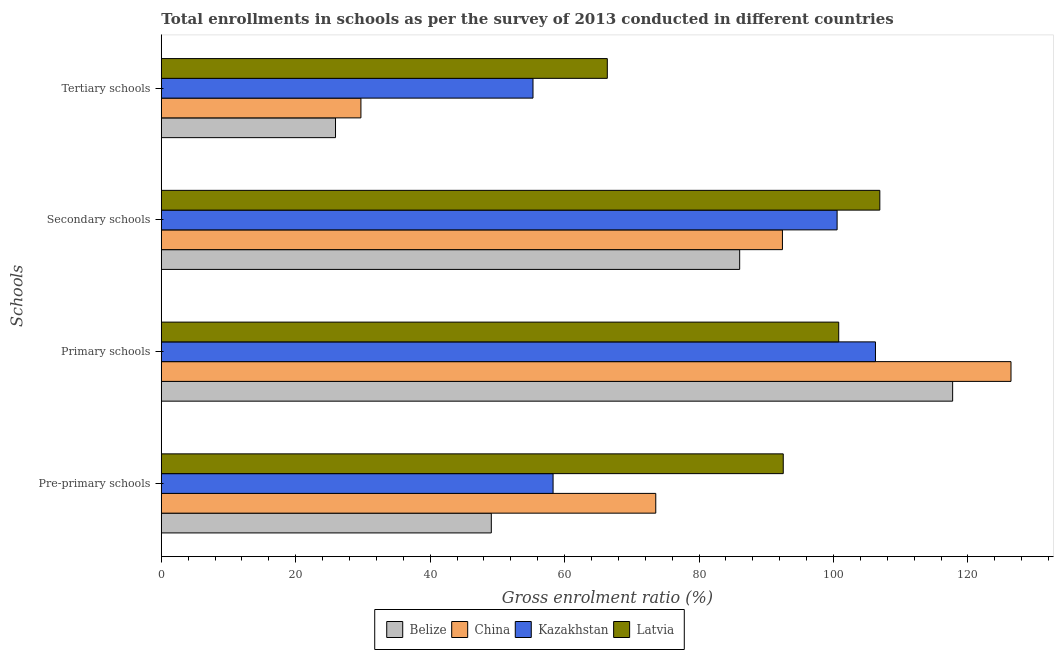How many different coloured bars are there?
Your response must be concise. 4. How many groups of bars are there?
Your answer should be compact. 4. Are the number of bars on each tick of the Y-axis equal?
Your response must be concise. Yes. How many bars are there on the 2nd tick from the top?
Your response must be concise. 4. What is the label of the 1st group of bars from the top?
Provide a short and direct response. Tertiary schools. What is the gross enrolment ratio in primary schools in Belize?
Your response must be concise. 117.73. Across all countries, what is the maximum gross enrolment ratio in tertiary schools?
Offer a terse response. 66.35. Across all countries, what is the minimum gross enrolment ratio in primary schools?
Keep it short and to the point. 100.78. In which country was the gross enrolment ratio in pre-primary schools maximum?
Provide a short and direct response. Latvia. In which country was the gross enrolment ratio in tertiary schools minimum?
Your response must be concise. Belize. What is the total gross enrolment ratio in secondary schools in the graph?
Offer a terse response. 385.9. What is the difference between the gross enrolment ratio in primary schools in Belize and that in Latvia?
Your answer should be very brief. 16.95. What is the difference between the gross enrolment ratio in pre-primary schools in Latvia and the gross enrolment ratio in primary schools in Kazakhstan?
Your answer should be very brief. -13.72. What is the average gross enrolment ratio in tertiary schools per country?
Ensure brevity in your answer.  44.32. What is the difference between the gross enrolment ratio in primary schools and gross enrolment ratio in secondary schools in Kazakhstan?
Ensure brevity in your answer.  5.71. What is the ratio of the gross enrolment ratio in secondary schools in Kazakhstan to that in Belize?
Ensure brevity in your answer.  1.17. Is the gross enrolment ratio in primary schools in Latvia less than that in China?
Provide a short and direct response. Yes. Is the difference between the gross enrolment ratio in primary schools in China and Kazakhstan greater than the difference between the gross enrolment ratio in secondary schools in China and Kazakhstan?
Provide a succinct answer. Yes. What is the difference between the highest and the second highest gross enrolment ratio in tertiary schools?
Keep it short and to the point. 11.06. What is the difference between the highest and the lowest gross enrolment ratio in pre-primary schools?
Make the answer very short. 43.43. Is the sum of the gross enrolment ratio in secondary schools in Latvia and Belize greater than the maximum gross enrolment ratio in pre-primary schools across all countries?
Offer a very short reply. Yes. What does the 2nd bar from the top in Secondary schools represents?
Your answer should be compact. Kazakhstan. What does the 4th bar from the bottom in Pre-primary schools represents?
Keep it short and to the point. Latvia. Is it the case that in every country, the sum of the gross enrolment ratio in pre-primary schools and gross enrolment ratio in primary schools is greater than the gross enrolment ratio in secondary schools?
Your response must be concise. Yes. Are all the bars in the graph horizontal?
Make the answer very short. Yes. How many countries are there in the graph?
Provide a succinct answer. 4. Where does the legend appear in the graph?
Keep it short and to the point. Bottom center. How are the legend labels stacked?
Give a very brief answer. Horizontal. What is the title of the graph?
Ensure brevity in your answer.  Total enrollments in schools as per the survey of 2013 conducted in different countries. What is the label or title of the X-axis?
Give a very brief answer. Gross enrolment ratio (%). What is the label or title of the Y-axis?
Keep it short and to the point. Schools. What is the Gross enrolment ratio (%) in Belize in Pre-primary schools?
Offer a very short reply. 49.1. What is the Gross enrolment ratio (%) of China in Pre-primary schools?
Your answer should be compact. 73.56. What is the Gross enrolment ratio (%) in Kazakhstan in Pre-primary schools?
Provide a succinct answer. 58.29. What is the Gross enrolment ratio (%) of Latvia in Pre-primary schools?
Keep it short and to the point. 92.53. What is the Gross enrolment ratio (%) in Belize in Primary schools?
Your response must be concise. 117.73. What is the Gross enrolment ratio (%) of China in Primary schools?
Keep it short and to the point. 126.42. What is the Gross enrolment ratio (%) in Kazakhstan in Primary schools?
Make the answer very short. 106.25. What is the Gross enrolment ratio (%) in Latvia in Primary schools?
Offer a terse response. 100.78. What is the Gross enrolment ratio (%) in Belize in Secondary schools?
Give a very brief answer. 86.05. What is the Gross enrolment ratio (%) of China in Secondary schools?
Your response must be concise. 92.41. What is the Gross enrolment ratio (%) in Kazakhstan in Secondary schools?
Your answer should be compact. 100.54. What is the Gross enrolment ratio (%) of Latvia in Secondary schools?
Your response must be concise. 106.9. What is the Gross enrolment ratio (%) in Belize in Tertiary schools?
Your response must be concise. 25.92. What is the Gross enrolment ratio (%) of China in Tertiary schools?
Your answer should be very brief. 29.7. What is the Gross enrolment ratio (%) of Kazakhstan in Tertiary schools?
Your answer should be compact. 55.3. What is the Gross enrolment ratio (%) of Latvia in Tertiary schools?
Offer a very short reply. 66.35. Across all Schools, what is the maximum Gross enrolment ratio (%) of Belize?
Offer a very short reply. 117.73. Across all Schools, what is the maximum Gross enrolment ratio (%) in China?
Provide a short and direct response. 126.42. Across all Schools, what is the maximum Gross enrolment ratio (%) of Kazakhstan?
Give a very brief answer. 106.25. Across all Schools, what is the maximum Gross enrolment ratio (%) in Latvia?
Provide a succinct answer. 106.9. Across all Schools, what is the minimum Gross enrolment ratio (%) in Belize?
Ensure brevity in your answer.  25.92. Across all Schools, what is the minimum Gross enrolment ratio (%) in China?
Give a very brief answer. 29.7. Across all Schools, what is the minimum Gross enrolment ratio (%) of Kazakhstan?
Provide a succinct answer. 55.3. Across all Schools, what is the minimum Gross enrolment ratio (%) of Latvia?
Your answer should be compact. 66.35. What is the total Gross enrolment ratio (%) of Belize in the graph?
Provide a short and direct response. 278.79. What is the total Gross enrolment ratio (%) in China in the graph?
Your response must be concise. 322.09. What is the total Gross enrolment ratio (%) in Kazakhstan in the graph?
Your answer should be very brief. 320.38. What is the total Gross enrolment ratio (%) in Latvia in the graph?
Offer a very short reply. 366.57. What is the difference between the Gross enrolment ratio (%) of Belize in Pre-primary schools and that in Primary schools?
Provide a succinct answer. -68.63. What is the difference between the Gross enrolment ratio (%) of China in Pre-primary schools and that in Primary schools?
Offer a very short reply. -52.85. What is the difference between the Gross enrolment ratio (%) of Kazakhstan in Pre-primary schools and that in Primary schools?
Provide a short and direct response. -47.96. What is the difference between the Gross enrolment ratio (%) in Latvia in Pre-primary schools and that in Primary schools?
Your answer should be very brief. -8.25. What is the difference between the Gross enrolment ratio (%) in Belize in Pre-primary schools and that in Secondary schools?
Your answer should be compact. -36.95. What is the difference between the Gross enrolment ratio (%) of China in Pre-primary schools and that in Secondary schools?
Provide a succinct answer. -18.84. What is the difference between the Gross enrolment ratio (%) in Kazakhstan in Pre-primary schools and that in Secondary schools?
Keep it short and to the point. -42.26. What is the difference between the Gross enrolment ratio (%) of Latvia in Pre-primary schools and that in Secondary schools?
Make the answer very short. -14.37. What is the difference between the Gross enrolment ratio (%) in Belize in Pre-primary schools and that in Tertiary schools?
Ensure brevity in your answer.  23.18. What is the difference between the Gross enrolment ratio (%) in China in Pre-primary schools and that in Tertiary schools?
Your response must be concise. 43.87. What is the difference between the Gross enrolment ratio (%) in Kazakhstan in Pre-primary schools and that in Tertiary schools?
Ensure brevity in your answer.  2.99. What is the difference between the Gross enrolment ratio (%) in Latvia in Pre-primary schools and that in Tertiary schools?
Your answer should be compact. 26.17. What is the difference between the Gross enrolment ratio (%) in Belize in Primary schools and that in Secondary schools?
Provide a short and direct response. 31.68. What is the difference between the Gross enrolment ratio (%) in China in Primary schools and that in Secondary schools?
Provide a short and direct response. 34.01. What is the difference between the Gross enrolment ratio (%) in Kazakhstan in Primary schools and that in Secondary schools?
Give a very brief answer. 5.71. What is the difference between the Gross enrolment ratio (%) in Latvia in Primary schools and that in Secondary schools?
Make the answer very short. -6.12. What is the difference between the Gross enrolment ratio (%) of Belize in Primary schools and that in Tertiary schools?
Make the answer very short. 91.82. What is the difference between the Gross enrolment ratio (%) of China in Primary schools and that in Tertiary schools?
Ensure brevity in your answer.  96.72. What is the difference between the Gross enrolment ratio (%) of Kazakhstan in Primary schools and that in Tertiary schools?
Ensure brevity in your answer.  50.95. What is the difference between the Gross enrolment ratio (%) in Latvia in Primary schools and that in Tertiary schools?
Provide a succinct answer. 34.43. What is the difference between the Gross enrolment ratio (%) of Belize in Secondary schools and that in Tertiary schools?
Provide a short and direct response. 60.13. What is the difference between the Gross enrolment ratio (%) in China in Secondary schools and that in Tertiary schools?
Your answer should be compact. 62.71. What is the difference between the Gross enrolment ratio (%) in Kazakhstan in Secondary schools and that in Tertiary schools?
Offer a terse response. 45.25. What is the difference between the Gross enrolment ratio (%) in Latvia in Secondary schools and that in Tertiary schools?
Give a very brief answer. 40.54. What is the difference between the Gross enrolment ratio (%) in Belize in Pre-primary schools and the Gross enrolment ratio (%) in China in Primary schools?
Offer a very short reply. -77.32. What is the difference between the Gross enrolment ratio (%) of Belize in Pre-primary schools and the Gross enrolment ratio (%) of Kazakhstan in Primary schools?
Make the answer very short. -57.15. What is the difference between the Gross enrolment ratio (%) of Belize in Pre-primary schools and the Gross enrolment ratio (%) of Latvia in Primary schools?
Ensure brevity in your answer.  -51.69. What is the difference between the Gross enrolment ratio (%) in China in Pre-primary schools and the Gross enrolment ratio (%) in Kazakhstan in Primary schools?
Keep it short and to the point. -32.69. What is the difference between the Gross enrolment ratio (%) of China in Pre-primary schools and the Gross enrolment ratio (%) of Latvia in Primary schools?
Keep it short and to the point. -27.22. What is the difference between the Gross enrolment ratio (%) in Kazakhstan in Pre-primary schools and the Gross enrolment ratio (%) in Latvia in Primary schools?
Keep it short and to the point. -42.5. What is the difference between the Gross enrolment ratio (%) in Belize in Pre-primary schools and the Gross enrolment ratio (%) in China in Secondary schools?
Your answer should be very brief. -43.31. What is the difference between the Gross enrolment ratio (%) in Belize in Pre-primary schools and the Gross enrolment ratio (%) in Kazakhstan in Secondary schools?
Provide a short and direct response. -51.45. What is the difference between the Gross enrolment ratio (%) of Belize in Pre-primary schools and the Gross enrolment ratio (%) of Latvia in Secondary schools?
Your response must be concise. -57.8. What is the difference between the Gross enrolment ratio (%) in China in Pre-primary schools and the Gross enrolment ratio (%) in Kazakhstan in Secondary schools?
Make the answer very short. -26.98. What is the difference between the Gross enrolment ratio (%) in China in Pre-primary schools and the Gross enrolment ratio (%) in Latvia in Secondary schools?
Offer a very short reply. -33.33. What is the difference between the Gross enrolment ratio (%) in Kazakhstan in Pre-primary schools and the Gross enrolment ratio (%) in Latvia in Secondary schools?
Keep it short and to the point. -48.61. What is the difference between the Gross enrolment ratio (%) of Belize in Pre-primary schools and the Gross enrolment ratio (%) of China in Tertiary schools?
Your response must be concise. 19.4. What is the difference between the Gross enrolment ratio (%) of Belize in Pre-primary schools and the Gross enrolment ratio (%) of Kazakhstan in Tertiary schools?
Your response must be concise. -6.2. What is the difference between the Gross enrolment ratio (%) of Belize in Pre-primary schools and the Gross enrolment ratio (%) of Latvia in Tertiary schools?
Your response must be concise. -17.26. What is the difference between the Gross enrolment ratio (%) of China in Pre-primary schools and the Gross enrolment ratio (%) of Kazakhstan in Tertiary schools?
Provide a succinct answer. 18.27. What is the difference between the Gross enrolment ratio (%) in China in Pre-primary schools and the Gross enrolment ratio (%) in Latvia in Tertiary schools?
Offer a very short reply. 7.21. What is the difference between the Gross enrolment ratio (%) in Kazakhstan in Pre-primary schools and the Gross enrolment ratio (%) in Latvia in Tertiary schools?
Provide a short and direct response. -8.07. What is the difference between the Gross enrolment ratio (%) of Belize in Primary schools and the Gross enrolment ratio (%) of China in Secondary schools?
Provide a succinct answer. 25.32. What is the difference between the Gross enrolment ratio (%) in Belize in Primary schools and the Gross enrolment ratio (%) in Kazakhstan in Secondary schools?
Provide a short and direct response. 17.19. What is the difference between the Gross enrolment ratio (%) in Belize in Primary schools and the Gross enrolment ratio (%) in Latvia in Secondary schools?
Offer a terse response. 10.83. What is the difference between the Gross enrolment ratio (%) of China in Primary schools and the Gross enrolment ratio (%) of Kazakhstan in Secondary schools?
Provide a short and direct response. 25.87. What is the difference between the Gross enrolment ratio (%) in China in Primary schools and the Gross enrolment ratio (%) in Latvia in Secondary schools?
Your answer should be very brief. 19.52. What is the difference between the Gross enrolment ratio (%) of Kazakhstan in Primary schools and the Gross enrolment ratio (%) of Latvia in Secondary schools?
Provide a short and direct response. -0.65. What is the difference between the Gross enrolment ratio (%) in Belize in Primary schools and the Gross enrolment ratio (%) in China in Tertiary schools?
Offer a terse response. 88.03. What is the difference between the Gross enrolment ratio (%) of Belize in Primary schools and the Gross enrolment ratio (%) of Kazakhstan in Tertiary schools?
Your answer should be very brief. 62.43. What is the difference between the Gross enrolment ratio (%) in Belize in Primary schools and the Gross enrolment ratio (%) in Latvia in Tertiary schools?
Offer a terse response. 51.38. What is the difference between the Gross enrolment ratio (%) of China in Primary schools and the Gross enrolment ratio (%) of Kazakhstan in Tertiary schools?
Your response must be concise. 71.12. What is the difference between the Gross enrolment ratio (%) in China in Primary schools and the Gross enrolment ratio (%) in Latvia in Tertiary schools?
Keep it short and to the point. 60.06. What is the difference between the Gross enrolment ratio (%) in Kazakhstan in Primary schools and the Gross enrolment ratio (%) in Latvia in Tertiary schools?
Make the answer very short. 39.9. What is the difference between the Gross enrolment ratio (%) of Belize in Secondary schools and the Gross enrolment ratio (%) of China in Tertiary schools?
Your response must be concise. 56.35. What is the difference between the Gross enrolment ratio (%) of Belize in Secondary schools and the Gross enrolment ratio (%) of Kazakhstan in Tertiary schools?
Give a very brief answer. 30.75. What is the difference between the Gross enrolment ratio (%) of Belize in Secondary schools and the Gross enrolment ratio (%) of Latvia in Tertiary schools?
Your response must be concise. 19.69. What is the difference between the Gross enrolment ratio (%) of China in Secondary schools and the Gross enrolment ratio (%) of Kazakhstan in Tertiary schools?
Provide a short and direct response. 37.11. What is the difference between the Gross enrolment ratio (%) of China in Secondary schools and the Gross enrolment ratio (%) of Latvia in Tertiary schools?
Your answer should be very brief. 26.05. What is the difference between the Gross enrolment ratio (%) of Kazakhstan in Secondary schools and the Gross enrolment ratio (%) of Latvia in Tertiary schools?
Offer a terse response. 34.19. What is the average Gross enrolment ratio (%) in Belize per Schools?
Your response must be concise. 69.7. What is the average Gross enrolment ratio (%) of China per Schools?
Your answer should be very brief. 80.52. What is the average Gross enrolment ratio (%) in Kazakhstan per Schools?
Provide a short and direct response. 80.09. What is the average Gross enrolment ratio (%) in Latvia per Schools?
Give a very brief answer. 91.64. What is the difference between the Gross enrolment ratio (%) of Belize and Gross enrolment ratio (%) of China in Pre-primary schools?
Offer a terse response. -24.47. What is the difference between the Gross enrolment ratio (%) of Belize and Gross enrolment ratio (%) of Kazakhstan in Pre-primary schools?
Offer a very short reply. -9.19. What is the difference between the Gross enrolment ratio (%) in Belize and Gross enrolment ratio (%) in Latvia in Pre-primary schools?
Your answer should be very brief. -43.43. What is the difference between the Gross enrolment ratio (%) in China and Gross enrolment ratio (%) in Kazakhstan in Pre-primary schools?
Give a very brief answer. 15.28. What is the difference between the Gross enrolment ratio (%) in China and Gross enrolment ratio (%) in Latvia in Pre-primary schools?
Ensure brevity in your answer.  -18.96. What is the difference between the Gross enrolment ratio (%) of Kazakhstan and Gross enrolment ratio (%) of Latvia in Pre-primary schools?
Offer a very short reply. -34.24. What is the difference between the Gross enrolment ratio (%) in Belize and Gross enrolment ratio (%) in China in Primary schools?
Your answer should be compact. -8.68. What is the difference between the Gross enrolment ratio (%) in Belize and Gross enrolment ratio (%) in Kazakhstan in Primary schools?
Your answer should be very brief. 11.48. What is the difference between the Gross enrolment ratio (%) in Belize and Gross enrolment ratio (%) in Latvia in Primary schools?
Provide a succinct answer. 16.95. What is the difference between the Gross enrolment ratio (%) of China and Gross enrolment ratio (%) of Kazakhstan in Primary schools?
Give a very brief answer. 20.17. What is the difference between the Gross enrolment ratio (%) of China and Gross enrolment ratio (%) of Latvia in Primary schools?
Offer a very short reply. 25.63. What is the difference between the Gross enrolment ratio (%) of Kazakhstan and Gross enrolment ratio (%) of Latvia in Primary schools?
Offer a very short reply. 5.47. What is the difference between the Gross enrolment ratio (%) in Belize and Gross enrolment ratio (%) in China in Secondary schools?
Your answer should be very brief. -6.36. What is the difference between the Gross enrolment ratio (%) of Belize and Gross enrolment ratio (%) of Kazakhstan in Secondary schools?
Ensure brevity in your answer.  -14.5. What is the difference between the Gross enrolment ratio (%) in Belize and Gross enrolment ratio (%) in Latvia in Secondary schools?
Your answer should be compact. -20.85. What is the difference between the Gross enrolment ratio (%) in China and Gross enrolment ratio (%) in Kazakhstan in Secondary schools?
Keep it short and to the point. -8.13. What is the difference between the Gross enrolment ratio (%) in China and Gross enrolment ratio (%) in Latvia in Secondary schools?
Keep it short and to the point. -14.49. What is the difference between the Gross enrolment ratio (%) of Kazakhstan and Gross enrolment ratio (%) of Latvia in Secondary schools?
Provide a succinct answer. -6.35. What is the difference between the Gross enrolment ratio (%) in Belize and Gross enrolment ratio (%) in China in Tertiary schools?
Offer a very short reply. -3.78. What is the difference between the Gross enrolment ratio (%) of Belize and Gross enrolment ratio (%) of Kazakhstan in Tertiary schools?
Provide a succinct answer. -29.38. What is the difference between the Gross enrolment ratio (%) of Belize and Gross enrolment ratio (%) of Latvia in Tertiary schools?
Keep it short and to the point. -40.44. What is the difference between the Gross enrolment ratio (%) of China and Gross enrolment ratio (%) of Kazakhstan in Tertiary schools?
Ensure brevity in your answer.  -25.6. What is the difference between the Gross enrolment ratio (%) in China and Gross enrolment ratio (%) in Latvia in Tertiary schools?
Your answer should be very brief. -36.66. What is the difference between the Gross enrolment ratio (%) in Kazakhstan and Gross enrolment ratio (%) in Latvia in Tertiary schools?
Offer a terse response. -11.06. What is the ratio of the Gross enrolment ratio (%) of Belize in Pre-primary schools to that in Primary schools?
Offer a very short reply. 0.42. What is the ratio of the Gross enrolment ratio (%) in China in Pre-primary schools to that in Primary schools?
Provide a short and direct response. 0.58. What is the ratio of the Gross enrolment ratio (%) in Kazakhstan in Pre-primary schools to that in Primary schools?
Your answer should be very brief. 0.55. What is the ratio of the Gross enrolment ratio (%) in Latvia in Pre-primary schools to that in Primary schools?
Keep it short and to the point. 0.92. What is the ratio of the Gross enrolment ratio (%) in Belize in Pre-primary schools to that in Secondary schools?
Your answer should be compact. 0.57. What is the ratio of the Gross enrolment ratio (%) of China in Pre-primary schools to that in Secondary schools?
Offer a very short reply. 0.8. What is the ratio of the Gross enrolment ratio (%) in Kazakhstan in Pre-primary schools to that in Secondary schools?
Offer a very short reply. 0.58. What is the ratio of the Gross enrolment ratio (%) of Latvia in Pre-primary schools to that in Secondary schools?
Offer a terse response. 0.87. What is the ratio of the Gross enrolment ratio (%) of Belize in Pre-primary schools to that in Tertiary schools?
Provide a succinct answer. 1.89. What is the ratio of the Gross enrolment ratio (%) in China in Pre-primary schools to that in Tertiary schools?
Ensure brevity in your answer.  2.48. What is the ratio of the Gross enrolment ratio (%) of Kazakhstan in Pre-primary schools to that in Tertiary schools?
Your answer should be very brief. 1.05. What is the ratio of the Gross enrolment ratio (%) in Latvia in Pre-primary schools to that in Tertiary schools?
Make the answer very short. 1.39. What is the ratio of the Gross enrolment ratio (%) in Belize in Primary schools to that in Secondary schools?
Offer a very short reply. 1.37. What is the ratio of the Gross enrolment ratio (%) in China in Primary schools to that in Secondary schools?
Your answer should be compact. 1.37. What is the ratio of the Gross enrolment ratio (%) in Kazakhstan in Primary schools to that in Secondary schools?
Your answer should be very brief. 1.06. What is the ratio of the Gross enrolment ratio (%) in Latvia in Primary schools to that in Secondary schools?
Give a very brief answer. 0.94. What is the ratio of the Gross enrolment ratio (%) of Belize in Primary schools to that in Tertiary schools?
Make the answer very short. 4.54. What is the ratio of the Gross enrolment ratio (%) of China in Primary schools to that in Tertiary schools?
Your answer should be compact. 4.26. What is the ratio of the Gross enrolment ratio (%) in Kazakhstan in Primary schools to that in Tertiary schools?
Your response must be concise. 1.92. What is the ratio of the Gross enrolment ratio (%) of Latvia in Primary schools to that in Tertiary schools?
Give a very brief answer. 1.52. What is the ratio of the Gross enrolment ratio (%) in Belize in Secondary schools to that in Tertiary schools?
Keep it short and to the point. 3.32. What is the ratio of the Gross enrolment ratio (%) in China in Secondary schools to that in Tertiary schools?
Provide a short and direct response. 3.11. What is the ratio of the Gross enrolment ratio (%) of Kazakhstan in Secondary schools to that in Tertiary schools?
Ensure brevity in your answer.  1.82. What is the ratio of the Gross enrolment ratio (%) in Latvia in Secondary schools to that in Tertiary schools?
Provide a short and direct response. 1.61. What is the difference between the highest and the second highest Gross enrolment ratio (%) in Belize?
Provide a succinct answer. 31.68. What is the difference between the highest and the second highest Gross enrolment ratio (%) of China?
Your answer should be compact. 34.01. What is the difference between the highest and the second highest Gross enrolment ratio (%) in Kazakhstan?
Provide a succinct answer. 5.71. What is the difference between the highest and the second highest Gross enrolment ratio (%) of Latvia?
Offer a terse response. 6.12. What is the difference between the highest and the lowest Gross enrolment ratio (%) in Belize?
Keep it short and to the point. 91.82. What is the difference between the highest and the lowest Gross enrolment ratio (%) of China?
Your answer should be very brief. 96.72. What is the difference between the highest and the lowest Gross enrolment ratio (%) of Kazakhstan?
Offer a very short reply. 50.95. What is the difference between the highest and the lowest Gross enrolment ratio (%) in Latvia?
Offer a terse response. 40.54. 